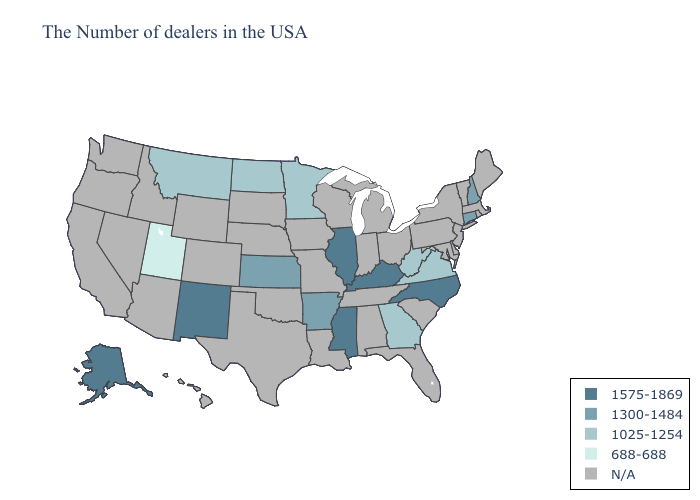Name the states that have a value in the range 1575-1869?
Quick response, please. North Carolina, Kentucky, Illinois, Mississippi, New Mexico, Alaska. Among the states that border Georgia , which have the highest value?
Be succinct. North Carolina. What is the lowest value in states that border Oklahoma?
Be succinct. 1300-1484. Name the states that have a value in the range N/A?
Short answer required. Maine, Massachusetts, Rhode Island, Vermont, New York, New Jersey, Delaware, Maryland, Pennsylvania, South Carolina, Ohio, Florida, Michigan, Indiana, Alabama, Tennessee, Wisconsin, Louisiana, Missouri, Iowa, Nebraska, Oklahoma, Texas, South Dakota, Wyoming, Colorado, Arizona, Idaho, Nevada, California, Washington, Oregon, Hawaii. Does Kentucky have the lowest value in the South?
Quick response, please. No. Which states have the lowest value in the Northeast?
Write a very short answer. New Hampshire, Connecticut. What is the value of Texas?
Give a very brief answer. N/A. What is the highest value in the West ?
Short answer required. 1575-1869. Name the states that have a value in the range 688-688?
Quick response, please. Utah. Name the states that have a value in the range 688-688?
Short answer required. Utah. Does the first symbol in the legend represent the smallest category?
Quick response, please. No. What is the value of Michigan?
Answer briefly. N/A. Among the states that border North Dakota , which have the highest value?
Quick response, please. Minnesota, Montana. Which states have the lowest value in the USA?
Keep it brief. Utah. Name the states that have a value in the range 688-688?
Be succinct. Utah. 